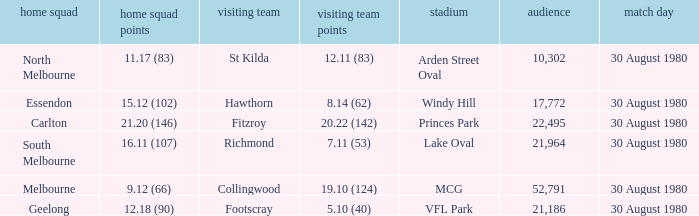What was the score for south melbourne at home? 16.11 (107). Give me the full table as a dictionary. {'header': ['home squad', 'home squad points', 'visiting team', 'visiting team points', 'stadium', 'audience', 'match day'], 'rows': [['North Melbourne', '11.17 (83)', 'St Kilda', '12.11 (83)', 'Arden Street Oval', '10,302', '30 August 1980'], ['Essendon', '15.12 (102)', 'Hawthorn', '8.14 (62)', 'Windy Hill', '17,772', '30 August 1980'], ['Carlton', '21.20 (146)', 'Fitzroy', '20.22 (142)', 'Princes Park', '22,495', '30 August 1980'], ['South Melbourne', '16.11 (107)', 'Richmond', '7.11 (53)', 'Lake Oval', '21,964', '30 August 1980'], ['Melbourne', '9.12 (66)', 'Collingwood', '19.10 (124)', 'MCG', '52,791', '30 August 1980'], ['Geelong', '12.18 (90)', 'Footscray', '5.10 (40)', 'VFL Park', '21,186', '30 August 1980']]} 